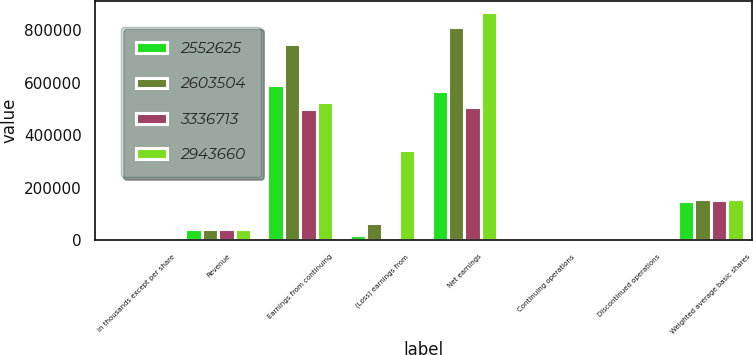<chart> <loc_0><loc_0><loc_500><loc_500><stacked_bar_chart><ecel><fcel>in thousands except per share<fcel>Revenue<fcel>Earnings from continuing<fcel>(Loss) earnings from<fcel>Net earnings<fcel>Continuing operations<fcel>Discontinued operations<fcel>Weighted average basic shares<nl><fcel>2.55262e+06<fcel>2018<fcel>42940<fcel>591145<fcel>20878<fcel>570267<fcel>3.94<fcel>0.14<fcel>149874<nl><fcel>2.6035e+06<fcel>2017<fcel>42940<fcel>746663<fcel>65002<fcel>811665<fcel>4.8<fcel>0.42<fcel>155685<nl><fcel>3.33671e+06<fcel>2016<fcel>42940<fcel>502128<fcel>6764<fcel>508892<fcel>3.23<fcel>0.04<fcel>155231<nl><fcel>2.94366e+06<fcel>2015<fcel>42940<fcel>525208<fcel>344621<fcel>869829<fcel>3.33<fcel>2.19<fcel>157619<nl></chart> 